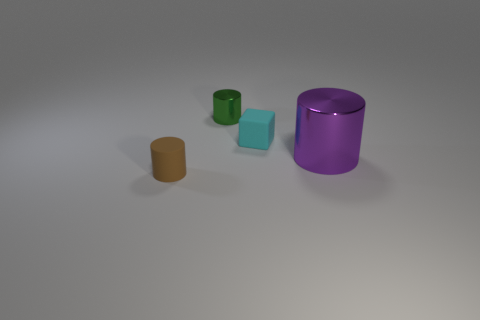Add 4 brown metal balls. How many objects exist? 8 Subtract all cubes. How many objects are left? 3 Subtract 0 gray blocks. How many objects are left? 4 Subtract all big purple metallic objects. Subtract all green metal things. How many objects are left? 2 Add 2 cyan matte blocks. How many cyan matte blocks are left? 3 Add 1 small things. How many small things exist? 4 